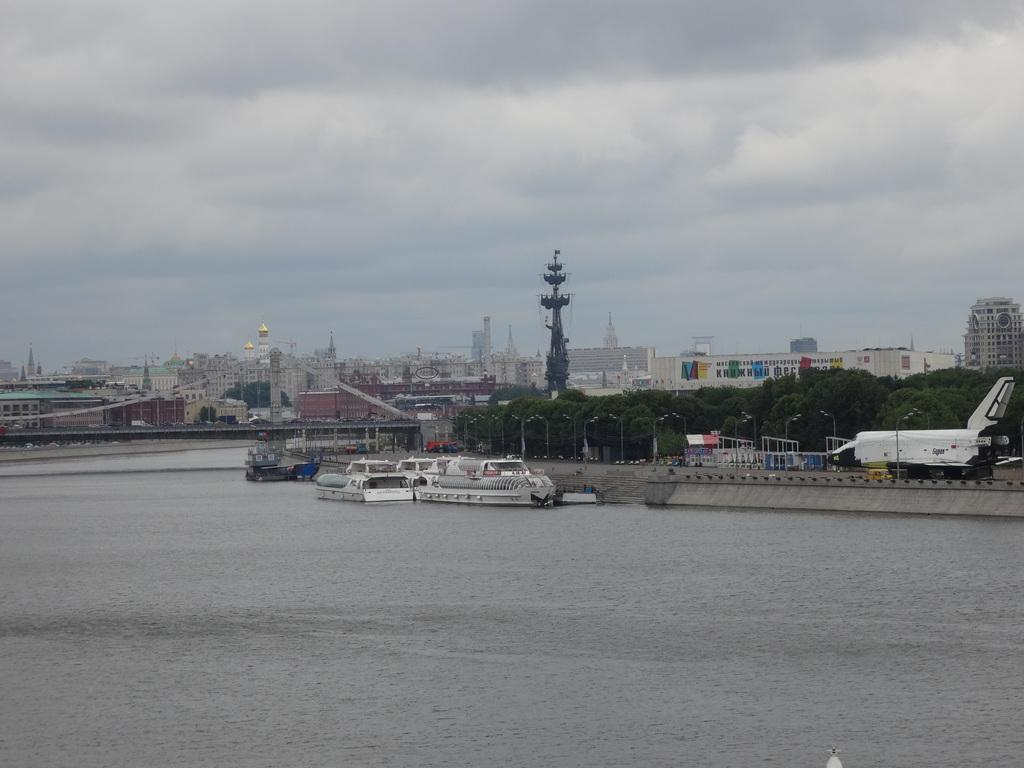What type of vehicles can be seen in the water in the image? There are boats in the water in the image. What structures are visible in the image? There are buildings visible in the image. What type of vegetation can be seen in the image? There are trees in the image. What type of lighting is present in the image? There are pole lights in the image. What is the condition of the sky in the image? The sky is cloudy in the image. What type of crate is visible in the image? There is no crate present in the image. What is the condition of the door in the image? There is no door present in the image. 